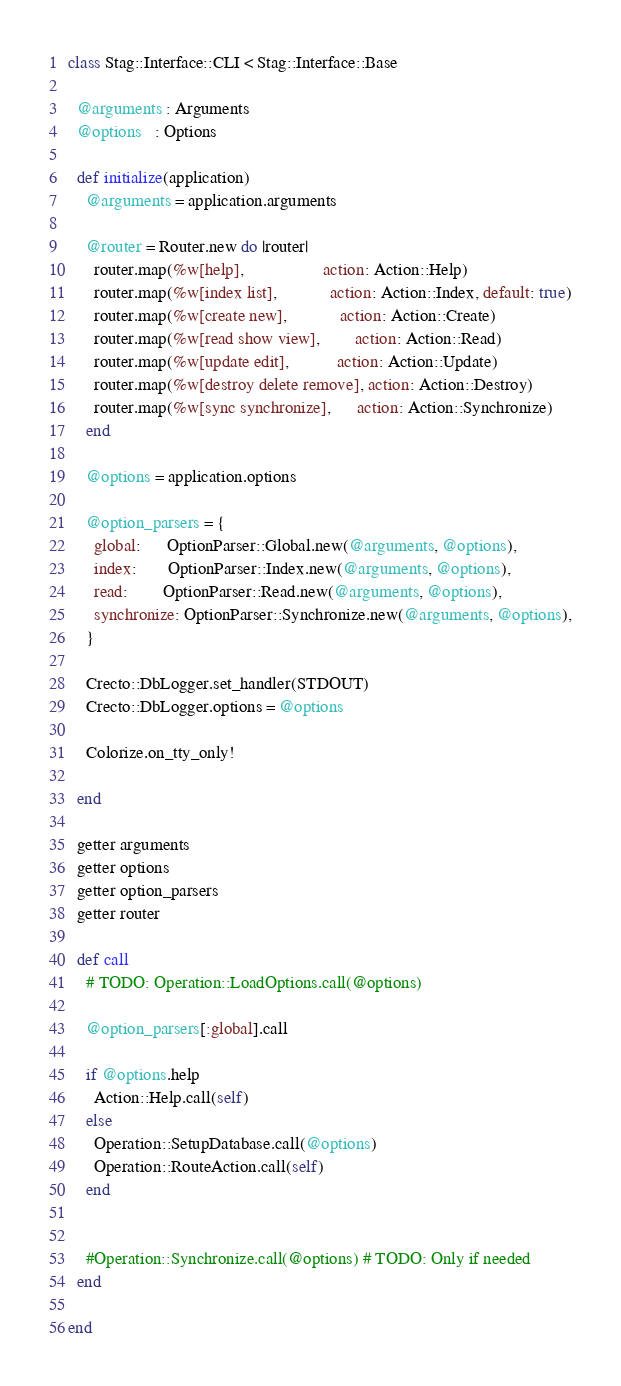Convert code to text. <code><loc_0><loc_0><loc_500><loc_500><_Crystal_>class Stag::Interface::CLI < Stag::Interface::Base

  @arguments : Arguments
  @options   : Options

  def initialize(application)
    @arguments = application.arguments

    @router = Router.new do |router|
      router.map(%w[help],                  action: Action::Help)
      router.map(%w[index list],            action: Action::Index, default: true)
      router.map(%w[create new],            action: Action::Create)
      router.map(%w[read show view],        action: Action::Read)
      router.map(%w[update edit],           action: Action::Update)
      router.map(%w[destroy delete remove], action: Action::Destroy)
      router.map(%w[sync synchronize],      action: Action::Synchronize)
    end

    @options = application.options

    @option_parsers = {
      global:      OptionParser::Global.new(@arguments, @options),
      index:       OptionParser::Index.new(@arguments, @options),
      read:        OptionParser::Read.new(@arguments, @options),
      synchronize: OptionParser::Synchronize.new(@arguments, @options),
    }

    Crecto::DbLogger.set_handler(STDOUT)
    Crecto::DbLogger.options = @options

    Colorize.on_tty_only!

  end

  getter arguments
  getter options
  getter option_parsers
  getter router

  def call
    # TODO: Operation::LoadOptions.call(@options)

    @option_parsers[:global].call

    if @options.help
      Action::Help.call(self)
    else
      Operation::SetupDatabase.call(@options)
      Operation::RouteAction.call(self)
    end


    #Operation::Synchronize.call(@options) # TODO: Only if needed
  end

end

</code> 